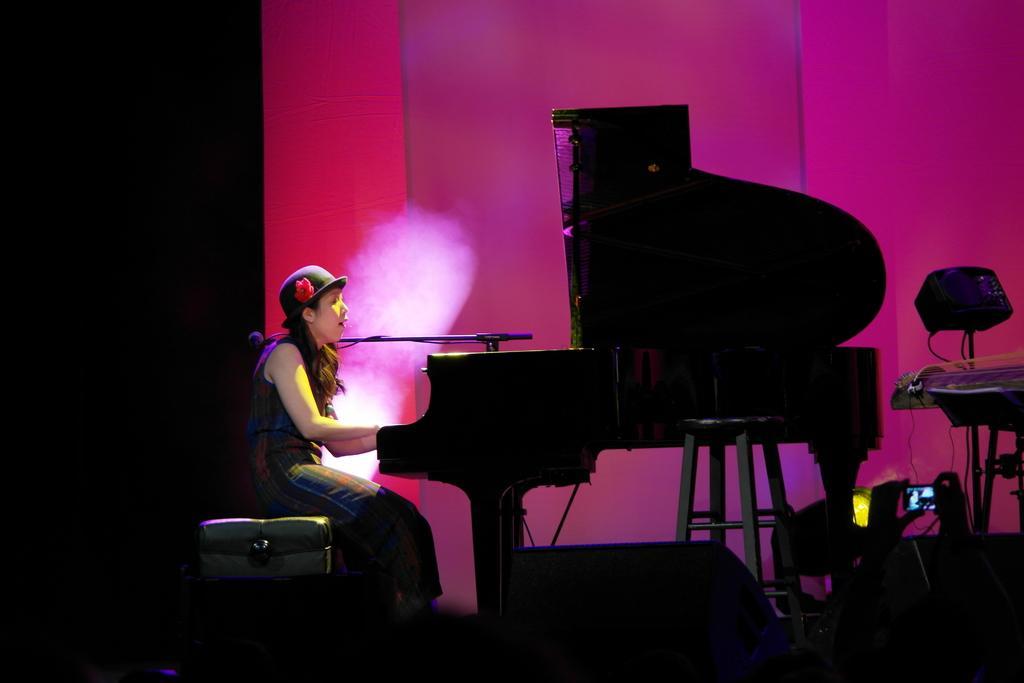Can you describe this image briefly? a woman sitting and playing piano with a microphone in front of her. 